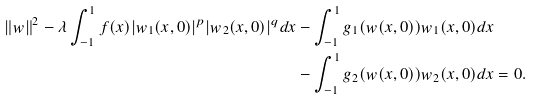Convert formula to latex. <formula><loc_0><loc_0><loc_500><loc_500>\| w \| ^ { 2 } - \lambda \int _ { - 1 } ^ { 1 } f ( x ) | w _ { 1 } ( x , 0 ) | ^ { p } | w _ { 2 } ( x , 0 ) | ^ { q } d x & - \int _ { - 1 } ^ { 1 } g _ { 1 } ( w ( x , 0 ) ) w _ { 1 } ( x , 0 ) d x \\ & - \int _ { - 1 } ^ { 1 } g _ { 2 } ( w ( x , 0 ) ) w _ { 2 } ( x , 0 ) d x = 0 .</formula> 